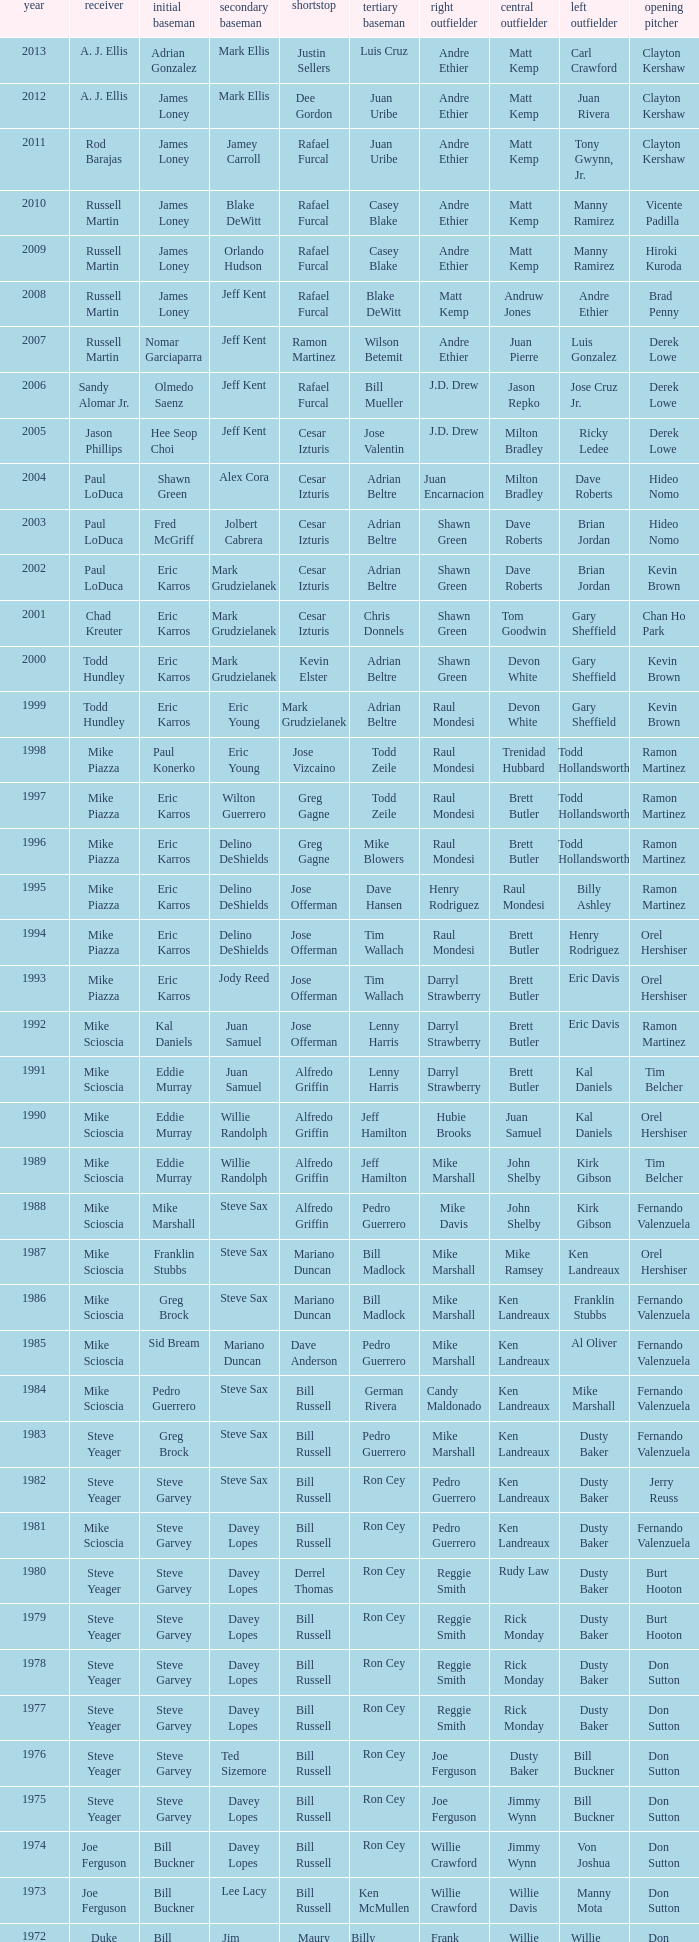Who was the SS when jim lefebvre was at 2nd, willie davis at CF, and don drysdale was the SP. Maury Wills. 